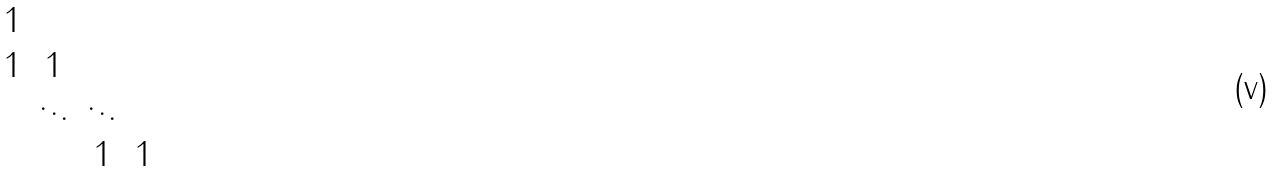<formula> <loc_0><loc_0><loc_500><loc_500>\begin{matrix} 1 & & & \\ 1 & 1 & & \\ & \ddots & \ddots & \\ & & 1 & 1 \end{matrix}</formula> 